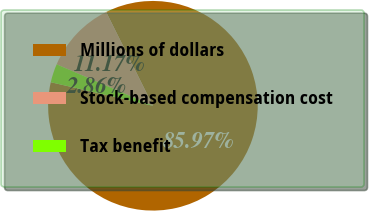Convert chart to OTSL. <chart><loc_0><loc_0><loc_500><loc_500><pie_chart><fcel>Millions of dollars<fcel>Stock-based compensation cost<fcel>Tax benefit<nl><fcel>85.96%<fcel>11.17%<fcel>2.86%<nl></chart> 